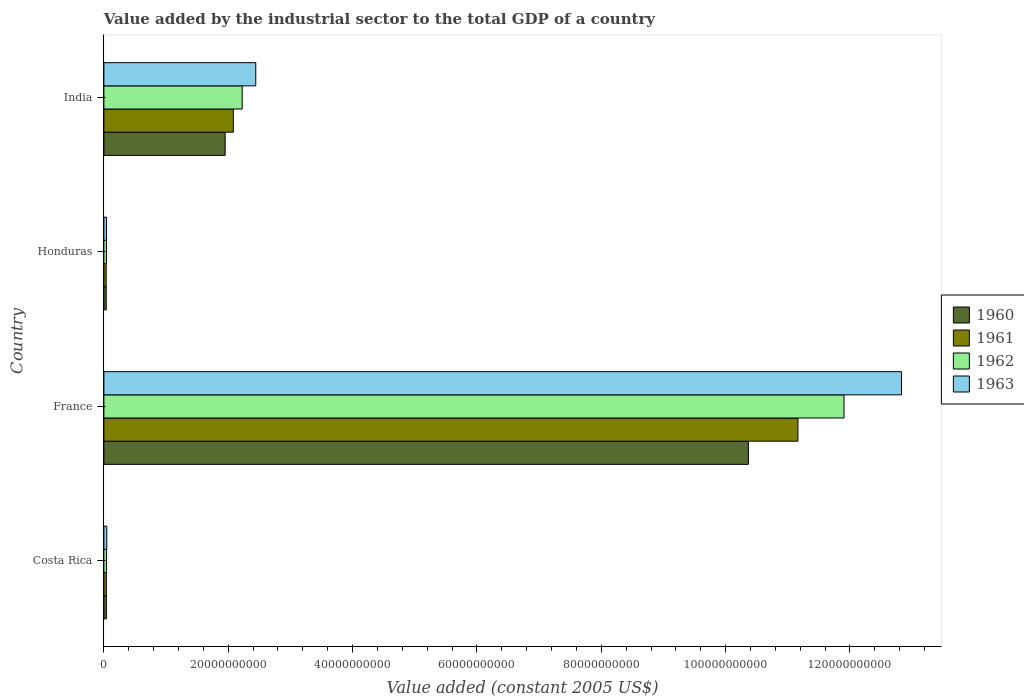How many different coloured bars are there?
Your answer should be very brief. 4. How many groups of bars are there?
Offer a terse response. 4. Are the number of bars on each tick of the Y-axis equal?
Provide a short and direct response. Yes. How many bars are there on the 2nd tick from the top?
Keep it short and to the point. 4. How many bars are there on the 1st tick from the bottom?
Provide a succinct answer. 4. What is the label of the 3rd group of bars from the top?
Ensure brevity in your answer.  France. In how many cases, is the number of bars for a given country not equal to the number of legend labels?
Your answer should be compact. 0. What is the value added by the industrial sector in 1961 in Costa Rica?
Make the answer very short. 3.94e+08. Across all countries, what is the maximum value added by the industrial sector in 1961?
Your answer should be very brief. 1.12e+11. Across all countries, what is the minimum value added by the industrial sector in 1963?
Keep it short and to the point. 4.23e+08. In which country was the value added by the industrial sector in 1963 maximum?
Ensure brevity in your answer.  France. In which country was the value added by the industrial sector in 1961 minimum?
Provide a succinct answer. Honduras. What is the total value added by the industrial sector in 1960 in the graph?
Ensure brevity in your answer.  1.24e+11. What is the difference between the value added by the industrial sector in 1960 in France and that in Honduras?
Provide a succinct answer. 1.03e+11. What is the difference between the value added by the industrial sector in 1960 in India and the value added by the industrial sector in 1962 in Honduras?
Provide a short and direct response. 1.91e+1. What is the average value added by the industrial sector in 1963 per country?
Make the answer very short. 3.84e+1. What is the difference between the value added by the industrial sector in 1962 and value added by the industrial sector in 1963 in Honduras?
Offer a very short reply. -7.19e+06. What is the ratio of the value added by the industrial sector in 1963 in Costa Rica to that in Honduras?
Offer a very short reply. 1.11. Is the difference between the value added by the industrial sector in 1962 in France and India greater than the difference between the value added by the industrial sector in 1963 in France and India?
Make the answer very short. No. What is the difference between the highest and the second highest value added by the industrial sector in 1961?
Offer a terse response. 9.08e+1. What is the difference between the highest and the lowest value added by the industrial sector in 1962?
Ensure brevity in your answer.  1.19e+11. Is it the case that in every country, the sum of the value added by the industrial sector in 1963 and value added by the industrial sector in 1960 is greater than the sum of value added by the industrial sector in 1962 and value added by the industrial sector in 1961?
Your answer should be very brief. No. What does the 4th bar from the top in France represents?
Your answer should be compact. 1960. What does the 4th bar from the bottom in Honduras represents?
Make the answer very short. 1963. Is it the case that in every country, the sum of the value added by the industrial sector in 1963 and value added by the industrial sector in 1961 is greater than the value added by the industrial sector in 1962?
Offer a very short reply. Yes. How many countries are there in the graph?
Ensure brevity in your answer.  4. What is the difference between two consecutive major ticks on the X-axis?
Your response must be concise. 2.00e+1. Where does the legend appear in the graph?
Make the answer very short. Center right. How are the legend labels stacked?
Make the answer very short. Vertical. What is the title of the graph?
Offer a very short reply. Value added by the industrial sector to the total GDP of a country. Does "1987" appear as one of the legend labels in the graph?
Provide a short and direct response. No. What is the label or title of the X-axis?
Keep it short and to the point. Value added (constant 2005 US$). What is the Value added (constant 2005 US$) of 1960 in Costa Rica?
Give a very brief answer. 3.98e+08. What is the Value added (constant 2005 US$) of 1961 in Costa Rica?
Offer a terse response. 3.94e+08. What is the Value added (constant 2005 US$) in 1962 in Costa Rica?
Offer a very short reply. 4.27e+08. What is the Value added (constant 2005 US$) of 1963 in Costa Rica?
Provide a short and direct response. 4.68e+08. What is the Value added (constant 2005 US$) in 1960 in France?
Make the answer very short. 1.04e+11. What is the Value added (constant 2005 US$) of 1961 in France?
Offer a terse response. 1.12e+11. What is the Value added (constant 2005 US$) of 1962 in France?
Offer a terse response. 1.19e+11. What is the Value added (constant 2005 US$) of 1963 in France?
Ensure brevity in your answer.  1.28e+11. What is the Value added (constant 2005 US$) of 1960 in Honduras?
Provide a succinct answer. 3.75e+08. What is the Value added (constant 2005 US$) in 1961 in Honduras?
Keep it short and to the point. 3.66e+08. What is the Value added (constant 2005 US$) in 1962 in Honduras?
Provide a succinct answer. 4.16e+08. What is the Value added (constant 2005 US$) in 1963 in Honduras?
Offer a terse response. 4.23e+08. What is the Value added (constant 2005 US$) of 1960 in India?
Your response must be concise. 1.95e+1. What is the Value added (constant 2005 US$) in 1961 in India?
Make the answer very short. 2.08e+1. What is the Value added (constant 2005 US$) in 1962 in India?
Offer a very short reply. 2.22e+1. What is the Value added (constant 2005 US$) in 1963 in India?
Make the answer very short. 2.44e+1. Across all countries, what is the maximum Value added (constant 2005 US$) in 1960?
Give a very brief answer. 1.04e+11. Across all countries, what is the maximum Value added (constant 2005 US$) in 1961?
Make the answer very short. 1.12e+11. Across all countries, what is the maximum Value added (constant 2005 US$) in 1962?
Give a very brief answer. 1.19e+11. Across all countries, what is the maximum Value added (constant 2005 US$) in 1963?
Give a very brief answer. 1.28e+11. Across all countries, what is the minimum Value added (constant 2005 US$) in 1960?
Your response must be concise. 3.75e+08. Across all countries, what is the minimum Value added (constant 2005 US$) of 1961?
Offer a terse response. 3.66e+08. Across all countries, what is the minimum Value added (constant 2005 US$) of 1962?
Your answer should be very brief. 4.16e+08. Across all countries, what is the minimum Value added (constant 2005 US$) of 1963?
Ensure brevity in your answer.  4.23e+08. What is the total Value added (constant 2005 US$) in 1960 in the graph?
Keep it short and to the point. 1.24e+11. What is the total Value added (constant 2005 US$) in 1961 in the graph?
Give a very brief answer. 1.33e+11. What is the total Value added (constant 2005 US$) in 1962 in the graph?
Your answer should be compact. 1.42e+11. What is the total Value added (constant 2005 US$) in 1963 in the graph?
Your response must be concise. 1.54e+11. What is the difference between the Value added (constant 2005 US$) of 1960 in Costa Rica and that in France?
Your answer should be very brief. -1.03e+11. What is the difference between the Value added (constant 2005 US$) of 1961 in Costa Rica and that in France?
Keep it short and to the point. -1.11e+11. What is the difference between the Value added (constant 2005 US$) of 1962 in Costa Rica and that in France?
Your answer should be very brief. -1.19e+11. What is the difference between the Value added (constant 2005 US$) in 1963 in Costa Rica and that in France?
Your answer should be very brief. -1.28e+11. What is the difference between the Value added (constant 2005 US$) in 1960 in Costa Rica and that in Honduras?
Provide a succinct answer. 2.26e+07. What is the difference between the Value added (constant 2005 US$) in 1961 in Costa Rica and that in Honduras?
Your response must be concise. 2.78e+07. What is the difference between the Value added (constant 2005 US$) of 1962 in Costa Rica and that in Honduras?
Provide a short and direct response. 1.10e+07. What is the difference between the Value added (constant 2005 US$) of 1963 in Costa Rica and that in Honduras?
Your answer should be very brief. 4.49e+07. What is the difference between the Value added (constant 2005 US$) in 1960 in Costa Rica and that in India?
Make the answer very short. -1.91e+1. What is the difference between the Value added (constant 2005 US$) of 1961 in Costa Rica and that in India?
Provide a succinct answer. -2.04e+1. What is the difference between the Value added (constant 2005 US$) in 1962 in Costa Rica and that in India?
Your answer should be compact. -2.18e+1. What is the difference between the Value added (constant 2005 US$) of 1963 in Costa Rica and that in India?
Keep it short and to the point. -2.40e+1. What is the difference between the Value added (constant 2005 US$) of 1960 in France and that in Honduras?
Keep it short and to the point. 1.03e+11. What is the difference between the Value added (constant 2005 US$) of 1961 in France and that in Honduras?
Offer a very short reply. 1.11e+11. What is the difference between the Value added (constant 2005 US$) of 1962 in France and that in Honduras?
Provide a succinct answer. 1.19e+11. What is the difference between the Value added (constant 2005 US$) in 1963 in France and that in Honduras?
Your response must be concise. 1.28e+11. What is the difference between the Value added (constant 2005 US$) in 1960 in France and that in India?
Provide a short and direct response. 8.42e+1. What is the difference between the Value added (constant 2005 US$) of 1961 in France and that in India?
Your answer should be very brief. 9.08e+1. What is the difference between the Value added (constant 2005 US$) of 1962 in France and that in India?
Your answer should be compact. 9.68e+1. What is the difference between the Value added (constant 2005 US$) of 1963 in France and that in India?
Make the answer very short. 1.04e+11. What is the difference between the Value added (constant 2005 US$) of 1960 in Honduras and that in India?
Your answer should be compact. -1.91e+1. What is the difference between the Value added (constant 2005 US$) of 1961 in Honduras and that in India?
Make the answer very short. -2.05e+1. What is the difference between the Value added (constant 2005 US$) of 1962 in Honduras and that in India?
Your answer should be compact. -2.18e+1. What is the difference between the Value added (constant 2005 US$) of 1963 in Honduras and that in India?
Your response must be concise. -2.40e+1. What is the difference between the Value added (constant 2005 US$) in 1960 in Costa Rica and the Value added (constant 2005 US$) in 1961 in France?
Provide a short and direct response. -1.11e+11. What is the difference between the Value added (constant 2005 US$) in 1960 in Costa Rica and the Value added (constant 2005 US$) in 1962 in France?
Keep it short and to the point. -1.19e+11. What is the difference between the Value added (constant 2005 US$) in 1960 in Costa Rica and the Value added (constant 2005 US$) in 1963 in France?
Your answer should be compact. -1.28e+11. What is the difference between the Value added (constant 2005 US$) of 1961 in Costa Rica and the Value added (constant 2005 US$) of 1962 in France?
Your answer should be very brief. -1.19e+11. What is the difference between the Value added (constant 2005 US$) in 1961 in Costa Rica and the Value added (constant 2005 US$) in 1963 in France?
Give a very brief answer. -1.28e+11. What is the difference between the Value added (constant 2005 US$) of 1962 in Costa Rica and the Value added (constant 2005 US$) of 1963 in France?
Offer a very short reply. -1.28e+11. What is the difference between the Value added (constant 2005 US$) of 1960 in Costa Rica and the Value added (constant 2005 US$) of 1961 in Honduras?
Make the answer very short. 3.20e+07. What is the difference between the Value added (constant 2005 US$) of 1960 in Costa Rica and the Value added (constant 2005 US$) of 1962 in Honduras?
Your response must be concise. -1.81e+07. What is the difference between the Value added (constant 2005 US$) in 1960 in Costa Rica and the Value added (constant 2005 US$) in 1963 in Honduras?
Offer a terse response. -2.52e+07. What is the difference between the Value added (constant 2005 US$) of 1961 in Costa Rica and the Value added (constant 2005 US$) of 1962 in Honduras?
Give a very brief answer. -2.22e+07. What is the difference between the Value added (constant 2005 US$) of 1961 in Costa Rica and the Value added (constant 2005 US$) of 1963 in Honduras?
Your answer should be compact. -2.94e+07. What is the difference between the Value added (constant 2005 US$) in 1962 in Costa Rica and the Value added (constant 2005 US$) in 1963 in Honduras?
Give a very brief answer. 3.81e+06. What is the difference between the Value added (constant 2005 US$) in 1960 in Costa Rica and the Value added (constant 2005 US$) in 1961 in India?
Offer a terse response. -2.04e+1. What is the difference between the Value added (constant 2005 US$) in 1960 in Costa Rica and the Value added (constant 2005 US$) in 1962 in India?
Provide a short and direct response. -2.18e+1. What is the difference between the Value added (constant 2005 US$) in 1960 in Costa Rica and the Value added (constant 2005 US$) in 1963 in India?
Give a very brief answer. -2.40e+1. What is the difference between the Value added (constant 2005 US$) in 1961 in Costa Rica and the Value added (constant 2005 US$) in 1962 in India?
Your answer should be compact. -2.19e+1. What is the difference between the Value added (constant 2005 US$) in 1961 in Costa Rica and the Value added (constant 2005 US$) in 1963 in India?
Provide a short and direct response. -2.40e+1. What is the difference between the Value added (constant 2005 US$) of 1962 in Costa Rica and the Value added (constant 2005 US$) of 1963 in India?
Keep it short and to the point. -2.40e+1. What is the difference between the Value added (constant 2005 US$) in 1960 in France and the Value added (constant 2005 US$) in 1961 in Honduras?
Provide a short and direct response. 1.03e+11. What is the difference between the Value added (constant 2005 US$) of 1960 in France and the Value added (constant 2005 US$) of 1962 in Honduras?
Ensure brevity in your answer.  1.03e+11. What is the difference between the Value added (constant 2005 US$) in 1960 in France and the Value added (constant 2005 US$) in 1963 in Honduras?
Make the answer very short. 1.03e+11. What is the difference between the Value added (constant 2005 US$) of 1961 in France and the Value added (constant 2005 US$) of 1962 in Honduras?
Offer a very short reply. 1.11e+11. What is the difference between the Value added (constant 2005 US$) in 1961 in France and the Value added (constant 2005 US$) in 1963 in Honduras?
Your answer should be compact. 1.11e+11. What is the difference between the Value added (constant 2005 US$) of 1962 in France and the Value added (constant 2005 US$) of 1963 in Honduras?
Give a very brief answer. 1.19e+11. What is the difference between the Value added (constant 2005 US$) in 1960 in France and the Value added (constant 2005 US$) in 1961 in India?
Your answer should be very brief. 8.28e+1. What is the difference between the Value added (constant 2005 US$) of 1960 in France and the Value added (constant 2005 US$) of 1962 in India?
Keep it short and to the point. 8.14e+1. What is the difference between the Value added (constant 2005 US$) of 1960 in France and the Value added (constant 2005 US$) of 1963 in India?
Keep it short and to the point. 7.92e+1. What is the difference between the Value added (constant 2005 US$) in 1961 in France and the Value added (constant 2005 US$) in 1962 in India?
Keep it short and to the point. 8.94e+1. What is the difference between the Value added (constant 2005 US$) of 1961 in France and the Value added (constant 2005 US$) of 1963 in India?
Provide a succinct answer. 8.72e+1. What is the difference between the Value added (constant 2005 US$) in 1962 in France and the Value added (constant 2005 US$) in 1963 in India?
Provide a short and direct response. 9.46e+1. What is the difference between the Value added (constant 2005 US$) of 1960 in Honduras and the Value added (constant 2005 US$) of 1961 in India?
Keep it short and to the point. -2.05e+1. What is the difference between the Value added (constant 2005 US$) of 1960 in Honduras and the Value added (constant 2005 US$) of 1962 in India?
Ensure brevity in your answer.  -2.19e+1. What is the difference between the Value added (constant 2005 US$) of 1960 in Honduras and the Value added (constant 2005 US$) of 1963 in India?
Make the answer very short. -2.41e+1. What is the difference between the Value added (constant 2005 US$) of 1961 in Honduras and the Value added (constant 2005 US$) of 1962 in India?
Ensure brevity in your answer.  -2.19e+1. What is the difference between the Value added (constant 2005 US$) of 1961 in Honduras and the Value added (constant 2005 US$) of 1963 in India?
Provide a short and direct response. -2.41e+1. What is the difference between the Value added (constant 2005 US$) in 1962 in Honduras and the Value added (constant 2005 US$) in 1963 in India?
Your answer should be compact. -2.40e+1. What is the average Value added (constant 2005 US$) in 1960 per country?
Provide a succinct answer. 3.10e+1. What is the average Value added (constant 2005 US$) in 1961 per country?
Offer a terse response. 3.33e+1. What is the average Value added (constant 2005 US$) in 1962 per country?
Offer a terse response. 3.55e+1. What is the average Value added (constant 2005 US$) of 1963 per country?
Provide a short and direct response. 3.84e+1. What is the difference between the Value added (constant 2005 US$) of 1960 and Value added (constant 2005 US$) of 1961 in Costa Rica?
Make the answer very short. 4.19e+06. What is the difference between the Value added (constant 2005 US$) of 1960 and Value added (constant 2005 US$) of 1962 in Costa Rica?
Your answer should be very brief. -2.91e+07. What is the difference between the Value added (constant 2005 US$) of 1960 and Value added (constant 2005 US$) of 1963 in Costa Rica?
Make the answer very short. -7.01e+07. What is the difference between the Value added (constant 2005 US$) of 1961 and Value added (constant 2005 US$) of 1962 in Costa Rica?
Give a very brief answer. -3.32e+07. What is the difference between the Value added (constant 2005 US$) in 1961 and Value added (constant 2005 US$) in 1963 in Costa Rica?
Ensure brevity in your answer.  -7.43e+07. What is the difference between the Value added (constant 2005 US$) of 1962 and Value added (constant 2005 US$) of 1963 in Costa Rica?
Give a very brief answer. -4.11e+07. What is the difference between the Value added (constant 2005 US$) of 1960 and Value added (constant 2005 US$) of 1961 in France?
Provide a short and direct response. -7.97e+09. What is the difference between the Value added (constant 2005 US$) in 1960 and Value added (constant 2005 US$) in 1962 in France?
Your answer should be compact. -1.54e+1. What is the difference between the Value added (constant 2005 US$) of 1960 and Value added (constant 2005 US$) of 1963 in France?
Keep it short and to the point. -2.46e+1. What is the difference between the Value added (constant 2005 US$) in 1961 and Value added (constant 2005 US$) in 1962 in France?
Provide a succinct answer. -7.41e+09. What is the difference between the Value added (constant 2005 US$) of 1961 and Value added (constant 2005 US$) of 1963 in France?
Provide a succinct answer. -1.67e+1. What is the difference between the Value added (constant 2005 US$) of 1962 and Value added (constant 2005 US$) of 1963 in France?
Offer a terse response. -9.25e+09. What is the difference between the Value added (constant 2005 US$) in 1960 and Value added (constant 2005 US$) in 1961 in Honduras?
Offer a very short reply. 9.37e+06. What is the difference between the Value added (constant 2005 US$) in 1960 and Value added (constant 2005 US$) in 1962 in Honduras?
Offer a terse response. -4.07e+07. What is the difference between the Value added (constant 2005 US$) of 1960 and Value added (constant 2005 US$) of 1963 in Honduras?
Make the answer very short. -4.79e+07. What is the difference between the Value added (constant 2005 US$) of 1961 and Value added (constant 2005 US$) of 1962 in Honduras?
Your answer should be very brief. -5.00e+07. What is the difference between the Value added (constant 2005 US$) in 1961 and Value added (constant 2005 US$) in 1963 in Honduras?
Offer a terse response. -5.72e+07. What is the difference between the Value added (constant 2005 US$) of 1962 and Value added (constant 2005 US$) of 1963 in Honduras?
Your answer should be very brief. -7.19e+06. What is the difference between the Value added (constant 2005 US$) of 1960 and Value added (constant 2005 US$) of 1961 in India?
Provide a short and direct response. -1.32e+09. What is the difference between the Value added (constant 2005 US$) of 1960 and Value added (constant 2005 US$) of 1962 in India?
Offer a terse response. -2.74e+09. What is the difference between the Value added (constant 2005 US$) of 1960 and Value added (constant 2005 US$) of 1963 in India?
Offer a very short reply. -4.92e+09. What is the difference between the Value added (constant 2005 US$) of 1961 and Value added (constant 2005 US$) of 1962 in India?
Ensure brevity in your answer.  -1.42e+09. What is the difference between the Value added (constant 2005 US$) of 1961 and Value added (constant 2005 US$) of 1963 in India?
Offer a very short reply. -3.60e+09. What is the difference between the Value added (constant 2005 US$) in 1962 and Value added (constant 2005 US$) in 1963 in India?
Ensure brevity in your answer.  -2.18e+09. What is the ratio of the Value added (constant 2005 US$) of 1960 in Costa Rica to that in France?
Keep it short and to the point. 0. What is the ratio of the Value added (constant 2005 US$) in 1961 in Costa Rica to that in France?
Offer a very short reply. 0. What is the ratio of the Value added (constant 2005 US$) in 1962 in Costa Rica to that in France?
Offer a terse response. 0. What is the ratio of the Value added (constant 2005 US$) in 1963 in Costa Rica to that in France?
Ensure brevity in your answer.  0. What is the ratio of the Value added (constant 2005 US$) of 1960 in Costa Rica to that in Honduras?
Your answer should be very brief. 1.06. What is the ratio of the Value added (constant 2005 US$) of 1961 in Costa Rica to that in Honduras?
Offer a very short reply. 1.08. What is the ratio of the Value added (constant 2005 US$) of 1962 in Costa Rica to that in Honduras?
Ensure brevity in your answer.  1.03. What is the ratio of the Value added (constant 2005 US$) in 1963 in Costa Rica to that in Honduras?
Your response must be concise. 1.11. What is the ratio of the Value added (constant 2005 US$) of 1960 in Costa Rica to that in India?
Provide a succinct answer. 0.02. What is the ratio of the Value added (constant 2005 US$) in 1961 in Costa Rica to that in India?
Give a very brief answer. 0.02. What is the ratio of the Value added (constant 2005 US$) in 1962 in Costa Rica to that in India?
Provide a short and direct response. 0.02. What is the ratio of the Value added (constant 2005 US$) in 1963 in Costa Rica to that in India?
Your answer should be compact. 0.02. What is the ratio of the Value added (constant 2005 US$) in 1960 in France to that in Honduras?
Give a very brief answer. 276.31. What is the ratio of the Value added (constant 2005 US$) of 1961 in France to that in Honduras?
Ensure brevity in your answer.  305.16. What is the ratio of the Value added (constant 2005 US$) in 1962 in France to that in Honduras?
Keep it short and to the point. 286.26. What is the ratio of the Value added (constant 2005 US$) of 1963 in France to that in Honduras?
Ensure brevity in your answer.  303.25. What is the ratio of the Value added (constant 2005 US$) of 1960 in France to that in India?
Your answer should be compact. 5.32. What is the ratio of the Value added (constant 2005 US$) of 1961 in France to that in India?
Provide a short and direct response. 5.36. What is the ratio of the Value added (constant 2005 US$) in 1962 in France to that in India?
Your response must be concise. 5.35. What is the ratio of the Value added (constant 2005 US$) in 1963 in France to that in India?
Make the answer very short. 5.25. What is the ratio of the Value added (constant 2005 US$) of 1960 in Honduras to that in India?
Keep it short and to the point. 0.02. What is the ratio of the Value added (constant 2005 US$) in 1961 in Honduras to that in India?
Offer a very short reply. 0.02. What is the ratio of the Value added (constant 2005 US$) of 1962 in Honduras to that in India?
Offer a very short reply. 0.02. What is the ratio of the Value added (constant 2005 US$) in 1963 in Honduras to that in India?
Offer a terse response. 0.02. What is the difference between the highest and the second highest Value added (constant 2005 US$) in 1960?
Offer a very short reply. 8.42e+1. What is the difference between the highest and the second highest Value added (constant 2005 US$) of 1961?
Your answer should be very brief. 9.08e+1. What is the difference between the highest and the second highest Value added (constant 2005 US$) of 1962?
Your answer should be very brief. 9.68e+1. What is the difference between the highest and the second highest Value added (constant 2005 US$) in 1963?
Offer a terse response. 1.04e+11. What is the difference between the highest and the lowest Value added (constant 2005 US$) in 1960?
Give a very brief answer. 1.03e+11. What is the difference between the highest and the lowest Value added (constant 2005 US$) in 1961?
Ensure brevity in your answer.  1.11e+11. What is the difference between the highest and the lowest Value added (constant 2005 US$) in 1962?
Give a very brief answer. 1.19e+11. What is the difference between the highest and the lowest Value added (constant 2005 US$) in 1963?
Make the answer very short. 1.28e+11. 